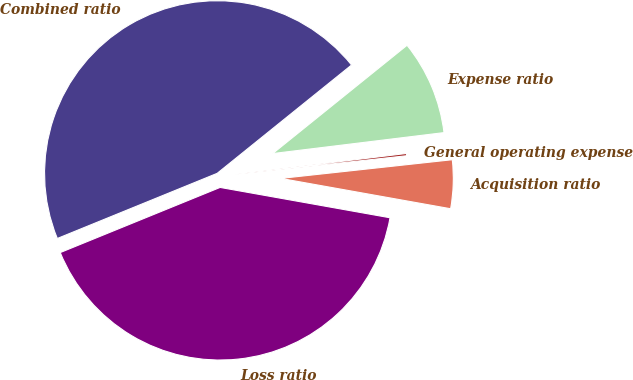<chart> <loc_0><loc_0><loc_500><loc_500><pie_chart><fcel>Loss ratio<fcel>Acquisition ratio<fcel>General operating expense<fcel>Expense ratio<fcel>Combined ratio<nl><fcel>41.03%<fcel>4.54%<fcel>0.21%<fcel>8.86%<fcel>45.36%<nl></chart> 